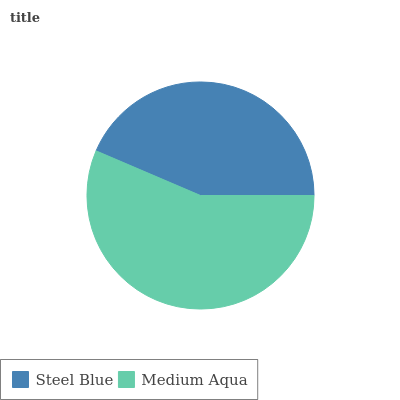Is Steel Blue the minimum?
Answer yes or no. Yes. Is Medium Aqua the maximum?
Answer yes or no. Yes. Is Medium Aqua the minimum?
Answer yes or no. No. Is Medium Aqua greater than Steel Blue?
Answer yes or no. Yes. Is Steel Blue less than Medium Aqua?
Answer yes or no. Yes. Is Steel Blue greater than Medium Aqua?
Answer yes or no. No. Is Medium Aqua less than Steel Blue?
Answer yes or no. No. Is Medium Aqua the high median?
Answer yes or no. Yes. Is Steel Blue the low median?
Answer yes or no. Yes. Is Steel Blue the high median?
Answer yes or no. No. Is Medium Aqua the low median?
Answer yes or no. No. 